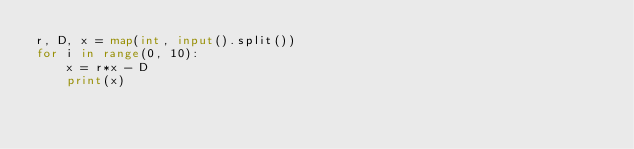<code> <loc_0><loc_0><loc_500><loc_500><_Python_>r, D, x = map(int, input().split())
for i in range(0, 10):
	x = r*x - D
	print(x)</code> 